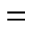<formula> <loc_0><loc_0><loc_500><loc_500>=</formula> 